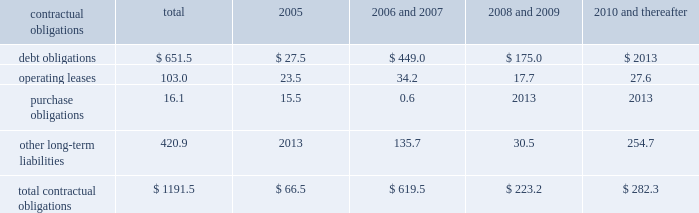Z i m m e r h o l d i n g s , i n c .
A n d s u b s i d i a r i e s 2 0 0 4 f o r m 1 0 - k contractual obligations the company has entered into contracts with various third parties in the normal course of business which will require future payments .
The table illustrates the company 2019s contractual obligations : 2006 2008 2010 and and and contractual obligations total 2005 2007 2009 thereafter .
Critical accounting estimates the financial results of the company are affected by the adequate provisions exist for income taxes for all periods and selection and application of accounting policies and methods .
Jurisdictions subject to review or audit .
Significant accounting policies which require management 2019s commitments and contingencies 2013 accruals for judgment are discussed below .
Product liability and other claims are established with excess inventory and instruments 2013 the company internal and external legal counsel based on current must determine as of each balance sheet date how much , if information and historical settlement information for claims , any , of its inventory may ultimately prove to be unsaleable or related fees and for claims incurred but not reported .
An unsaleable at its carrying cost .
Similarly , the company must actuarial model is used by the company to assist also determine if instruments on hand will be put to management in determining an appropriate level of accruals productive use or remain undeployed as a result of excess for product liability claims .
Historical patterns of claim loss supply .
Reserves are established to effectively adjust development over time are statistically analyzed to arrive at inventory and instruments to net realizable value .
To factors which are then applied to loss estimates in the determine the appropriate level of reserves , the company actuarial model .
The amounts established represent evaluates current stock levels in relation to historical and management 2019s best estimate of the ultimate costs that it will expected patterns of demand for all of its products and incur under the various contingencies .
Instrument systems and components .
The basis for the goodwill and intangible assets 2013 the company determination is generally the same for all inventory and evaluates the carrying value of goodwill and indefinite life instrument items and categories except for work-in-progress intangible assets annually , or whenever events or inventory , which is recorded at cost .
Obsolete or circumstances indicate the carrying value may not be discontinued items are generally destroyed and completely recoverable .
The company evaluates the carrying value of written off .
Management evaluates the need for changes to finite life intangible assets whenever events or circumstances valuation reserves based on market conditions , competitive indicate the carrying value may not be recoverable .
Offerings and other factors on a regular basis .
Significant assumptions are required to estimate the fair income taxes 2013 the company estimates income tax value of goodwill and intangible assets , most notably expense and income tax liabilities and assets by taxable estimated future cash flows generated by these assets .
Jurisdiction .
Realization of deferred tax assets in each taxable changes to these assumptions could result in the company jurisdiction is dependent on the company 2019s ability to being required to record impairment charges on these assets .
Generate future taxable income sufficient to realize the benefits .
The company evaluates deferred tax assets on an recent accounting pronouncements ongoing basis and provides valuation allowances if it is information about recent accounting pronouncements is determined to be 2018 2018more likely than not 2019 2019 that the deferred tax included in note 2 to the consolidated financial statements , benefit will not be realized .
Federal income taxes are which are included herein under item 8 .
Provided on the portion of the income of foreign subsidiaries that is expected to be remitted to the u.s .
The company operates within numerous taxing jurisdictions .
The company is subject to regulatory review or audit in virtually all of those jurisdictions and those reviews and audits may require extended periods of time to resolve .
The company makes use of all available information and makes reasoned judgments regarding matters requiring interpretation in establishing tax expense , liabilities and reserves .
The company believes .
What percentage of debt obligations are due 2006 and 2007? 
Computations: (449.0 / 651.5)
Answer: 0.68918. Z i m m e r h o l d i n g s , i n c .
A n d s u b s i d i a r i e s 2 0 0 4 f o r m 1 0 - k contractual obligations the company has entered into contracts with various third parties in the normal course of business which will require future payments .
The table illustrates the company 2019s contractual obligations : 2006 2008 2010 and and and contractual obligations total 2005 2007 2009 thereafter .
Critical accounting estimates the financial results of the company are affected by the adequate provisions exist for income taxes for all periods and selection and application of accounting policies and methods .
Jurisdictions subject to review or audit .
Significant accounting policies which require management 2019s commitments and contingencies 2013 accruals for judgment are discussed below .
Product liability and other claims are established with excess inventory and instruments 2013 the company internal and external legal counsel based on current must determine as of each balance sheet date how much , if information and historical settlement information for claims , any , of its inventory may ultimately prove to be unsaleable or related fees and for claims incurred but not reported .
An unsaleable at its carrying cost .
Similarly , the company must actuarial model is used by the company to assist also determine if instruments on hand will be put to management in determining an appropriate level of accruals productive use or remain undeployed as a result of excess for product liability claims .
Historical patterns of claim loss supply .
Reserves are established to effectively adjust development over time are statistically analyzed to arrive at inventory and instruments to net realizable value .
To factors which are then applied to loss estimates in the determine the appropriate level of reserves , the company actuarial model .
The amounts established represent evaluates current stock levels in relation to historical and management 2019s best estimate of the ultimate costs that it will expected patterns of demand for all of its products and incur under the various contingencies .
Instrument systems and components .
The basis for the goodwill and intangible assets 2013 the company determination is generally the same for all inventory and evaluates the carrying value of goodwill and indefinite life instrument items and categories except for work-in-progress intangible assets annually , or whenever events or inventory , which is recorded at cost .
Obsolete or circumstances indicate the carrying value may not be discontinued items are generally destroyed and completely recoverable .
The company evaluates the carrying value of written off .
Management evaluates the need for changes to finite life intangible assets whenever events or circumstances valuation reserves based on market conditions , competitive indicate the carrying value may not be recoverable .
Offerings and other factors on a regular basis .
Significant assumptions are required to estimate the fair income taxes 2013 the company estimates income tax value of goodwill and intangible assets , most notably expense and income tax liabilities and assets by taxable estimated future cash flows generated by these assets .
Jurisdiction .
Realization of deferred tax assets in each taxable changes to these assumptions could result in the company jurisdiction is dependent on the company 2019s ability to being required to record impairment charges on these assets .
Generate future taxable income sufficient to realize the benefits .
The company evaluates deferred tax assets on an recent accounting pronouncements ongoing basis and provides valuation allowances if it is information about recent accounting pronouncements is determined to be 2018 2018more likely than not 2019 2019 that the deferred tax included in note 2 to the consolidated financial statements , benefit will not be realized .
Federal income taxes are which are included herein under item 8 .
Provided on the portion of the income of foreign subsidiaries that is expected to be remitted to the u.s .
The company operates within numerous taxing jurisdictions .
The company is subject to regulatory review or audit in virtually all of those jurisdictions and those reviews and audits may require extended periods of time to resolve .
The company makes use of all available information and makes reasoned judgments regarding matters requiring interpretation in establishing tax expense , liabilities and reserves .
The company believes .
What percentage of debt obligations are due in 2005? 
Computations: (27.5 / 651.5)
Answer: 0.04221. 